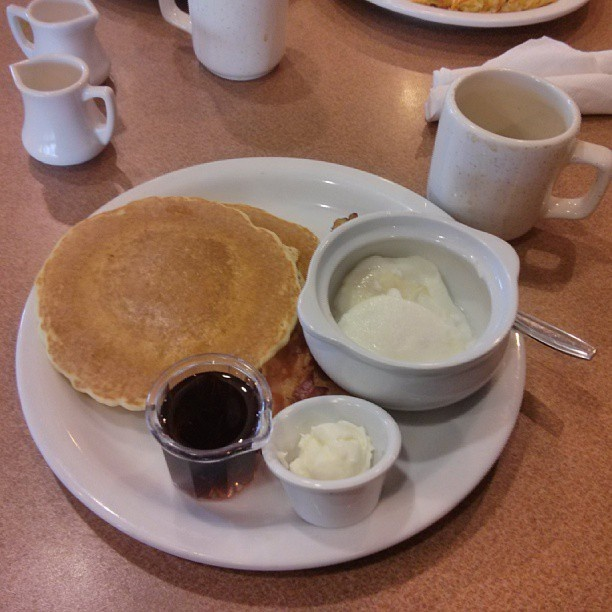Describe the objects in this image and their specific colors. I can see dining table in brown and maroon tones, bowl in brown, darkgray, and gray tones, cup in brown, gray, and darkgray tones, cup in brown, black, gray, and maroon tones, and cup in brown, darkgray, gray, and tan tones in this image. 